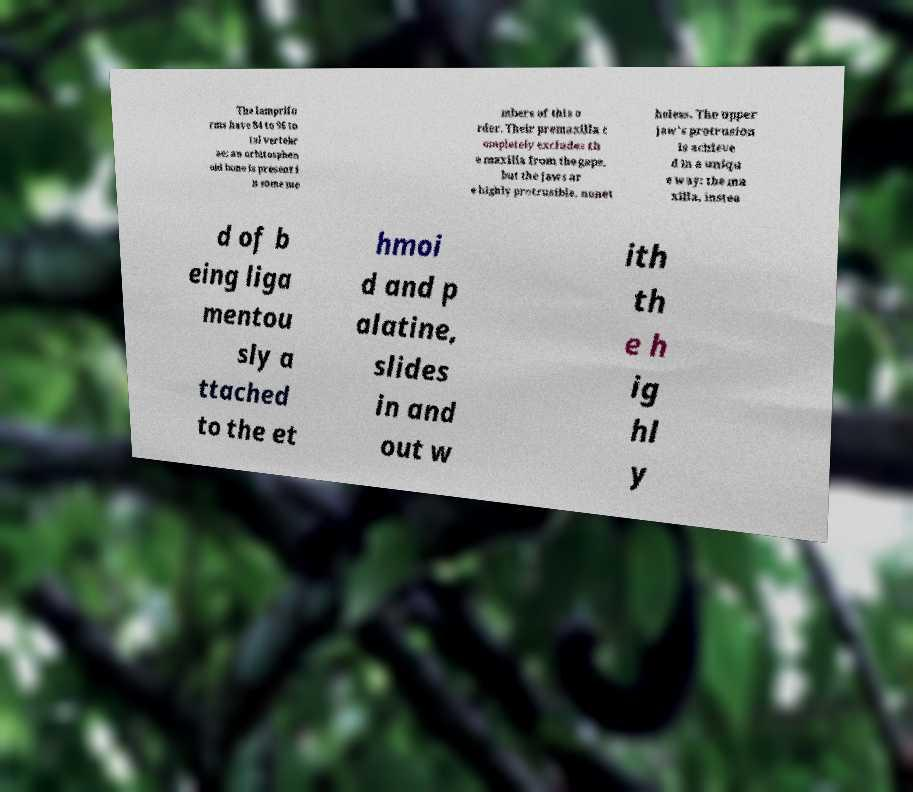Could you assist in decoding the text presented in this image and type it out clearly? The lamprifo rms have 84 to 96 to tal vertebr ae; an orbitosphen oid bone is present i n some me mbers of this o rder. Their premaxilla c ompletely excludes th e maxilla from the gape, but the jaws ar e highly protrusible, nonet heless. The upper jaw's protrusion is achieve d in a uniqu e way: the ma xilla, instea d of b eing liga mentou sly a ttached to the et hmoi d and p alatine, slides in and out w ith th e h ig hl y 